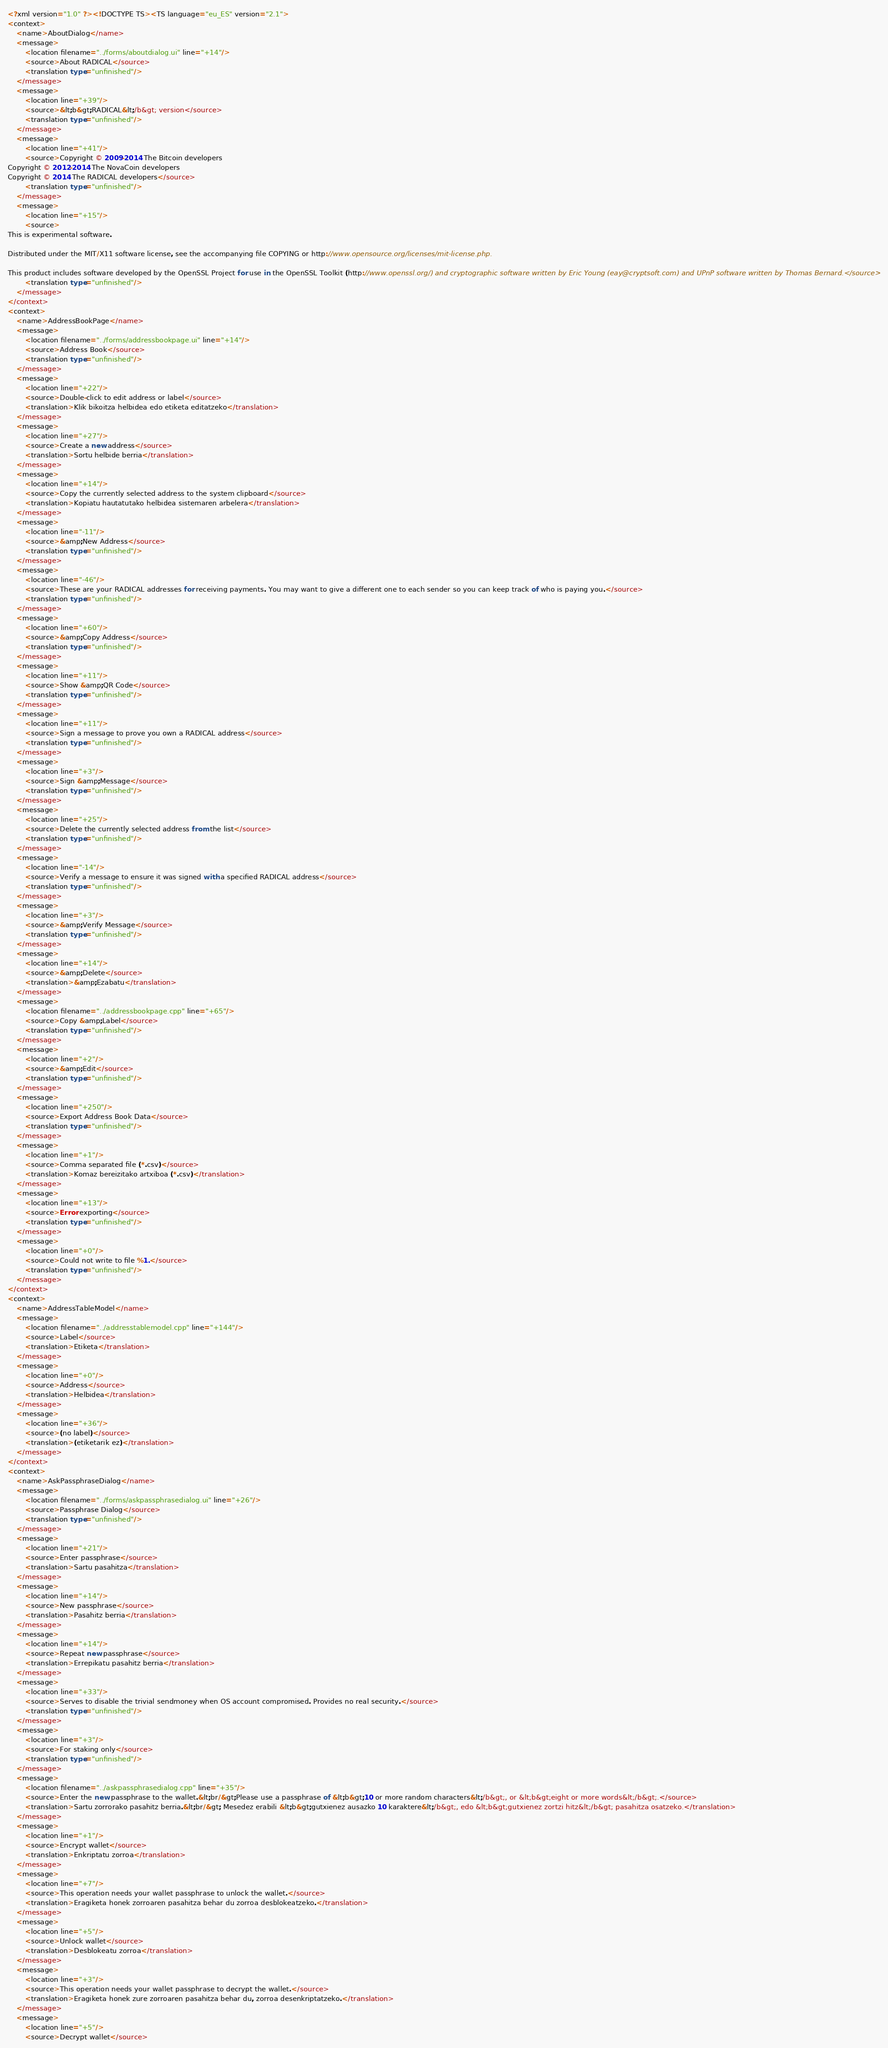<code> <loc_0><loc_0><loc_500><loc_500><_TypeScript_><?xml version="1.0" ?><!DOCTYPE TS><TS language="eu_ES" version="2.1">
<context>
    <name>AboutDialog</name>
    <message>
        <location filename="../forms/aboutdialog.ui" line="+14"/>
        <source>About RADICAL</source>
        <translation type="unfinished"/>
    </message>
    <message>
        <location line="+39"/>
        <source>&lt;b&gt;RADICAL&lt;/b&gt; version</source>
        <translation type="unfinished"/>
    </message>
    <message>
        <location line="+41"/>
        <source>Copyright © 2009-2014 The Bitcoin developers
Copyright © 2012-2014 The NovaCoin developers
Copyright © 2014 The RADICAL developers</source>
        <translation type="unfinished"/>
    </message>
    <message>
        <location line="+15"/>
        <source>
This is experimental software.

Distributed under the MIT/X11 software license, see the accompanying file COPYING or http://www.opensource.org/licenses/mit-license.php.

This product includes software developed by the OpenSSL Project for use in the OpenSSL Toolkit (http://www.openssl.org/) and cryptographic software written by Eric Young (eay@cryptsoft.com) and UPnP software written by Thomas Bernard.</source>
        <translation type="unfinished"/>
    </message>
</context>
<context>
    <name>AddressBookPage</name>
    <message>
        <location filename="../forms/addressbookpage.ui" line="+14"/>
        <source>Address Book</source>
        <translation type="unfinished"/>
    </message>
    <message>
        <location line="+22"/>
        <source>Double-click to edit address or label</source>
        <translation>Klik bikoitza helbidea edo etiketa editatzeko</translation>
    </message>
    <message>
        <location line="+27"/>
        <source>Create a new address</source>
        <translation>Sortu helbide berria</translation>
    </message>
    <message>
        <location line="+14"/>
        <source>Copy the currently selected address to the system clipboard</source>
        <translation>Kopiatu hautatutako helbidea sistemaren arbelera</translation>
    </message>
    <message>
        <location line="-11"/>
        <source>&amp;New Address</source>
        <translation type="unfinished"/>
    </message>
    <message>
        <location line="-46"/>
        <source>These are your RADICAL addresses for receiving payments. You may want to give a different one to each sender so you can keep track of who is paying you.</source>
        <translation type="unfinished"/>
    </message>
    <message>
        <location line="+60"/>
        <source>&amp;Copy Address</source>
        <translation type="unfinished"/>
    </message>
    <message>
        <location line="+11"/>
        <source>Show &amp;QR Code</source>
        <translation type="unfinished"/>
    </message>
    <message>
        <location line="+11"/>
        <source>Sign a message to prove you own a RADICAL address</source>
        <translation type="unfinished"/>
    </message>
    <message>
        <location line="+3"/>
        <source>Sign &amp;Message</source>
        <translation type="unfinished"/>
    </message>
    <message>
        <location line="+25"/>
        <source>Delete the currently selected address from the list</source>
        <translation type="unfinished"/>
    </message>
    <message>
        <location line="-14"/>
        <source>Verify a message to ensure it was signed with a specified RADICAL address</source>
        <translation type="unfinished"/>
    </message>
    <message>
        <location line="+3"/>
        <source>&amp;Verify Message</source>
        <translation type="unfinished"/>
    </message>
    <message>
        <location line="+14"/>
        <source>&amp;Delete</source>
        <translation>&amp;Ezabatu</translation>
    </message>
    <message>
        <location filename="../addressbookpage.cpp" line="+65"/>
        <source>Copy &amp;Label</source>
        <translation type="unfinished"/>
    </message>
    <message>
        <location line="+2"/>
        <source>&amp;Edit</source>
        <translation type="unfinished"/>
    </message>
    <message>
        <location line="+250"/>
        <source>Export Address Book Data</source>
        <translation type="unfinished"/>
    </message>
    <message>
        <location line="+1"/>
        <source>Comma separated file (*.csv)</source>
        <translation>Komaz bereizitako artxiboa (*.csv)</translation>
    </message>
    <message>
        <location line="+13"/>
        <source>Error exporting</source>
        <translation type="unfinished"/>
    </message>
    <message>
        <location line="+0"/>
        <source>Could not write to file %1.</source>
        <translation type="unfinished"/>
    </message>
</context>
<context>
    <name>AddressTableModel</name>
    <message>
        <location filename="../addresstablemodel.cpp" line="+144"/>
        <source>Label</source>
        <translation>Etiketa</translation>
    </message>
    <message>
        <location line="+0"/>
        <source>Address</source>
        <translation>Helbidea</translation>
    </message>
    <message>
        <location line="+36"/>
        <source>(no label)</source>
        <translation>(etiketarik ez)</translation>
    </message>
</context>
<context>
    <name>AskPassphraseDialog</name>
    <message>
        <location filename="../forms/askpassphrasedialog.ui" line="+26"/>
        <source>Passphrase Dialog</source>
        <translation type="unfinished"/>
    </message>
    <message>
        <location line="+21"/>
        <source>Enter passphrase</source>
        <translation>Sartu pasahitza</translation>
    </message>
    <message>
        <location line="+14"/>
        <source>New passphrase</source>
        <translation>Pasahitz berria</translation>
    </message>
    <message>
        <location line="+14"/>
        <source>Repeat new passphrase</source>
        <translation>Errepikatu pasahitz berria</translation>
    </message>
    <message>
        <location line="+33"/>
        <source>Serves to disable the trivial sendmoney when OS account compromised. Provides no real security.</source>
        <translation type="unfinished"/>
    </message>
    <message>
        <location line="+3"/>
        <source>For staking only</source>
        <translation type="unfinished"/>
    </message>
    <message>
        <location filename="../askpassphrasedialog.cpp" line="+35"/>
        <source>Enter the new passphrase to the wallet.&lt;br/&gt;Please use a passphrase of &lt;b&gt;10 or more random characters&lt;/b&gt;, or &lt;b&gt;eight or more words&lt;/b&gt;.</source>
        <translation>Sartu zorrorako pasahitz berria.&lt;br/&gt; Mesedez erabili &lt;b&gt;gutxienez ausazko 10 karaktere&lt;/b&gt;, edo &lt;b&gt;gutxienez zortzi hitz&lt;/b&gt; pasahitza osatzeko.</translation>
    </message>
    <message>
        <location line="+1"/>
        <source>Encrypt wallet</source>
        <translation>Enkriptatu zorroa</translation>
    </message>
    <message>
        <location line="+7"/>
        <source>This operation needs your wallet passphrase to unlock the wallet.</source>
        <translation>Eragiketa honek zorroaren pasahitza behar du zorroa desblokeatzeko.</translation>
    </message>
    <message>
        <location line="+5"/>
        <source>Unlock wallet</source>
        <translation>Desblokeatu zorroa</translation>
    </message>
    <message>
        <location line="+3"/>
        <source>This operation needs your wallet passphrase to decrypt the wallet.</source>
        <translation>Eragiketa honek zure zorroaren pasahitza behar du, zorroa desenkriptatzeko.</translation>
    </message>
    <message>
        <location line="+5"/>
        <source>Decrypt wallet</source></code> 